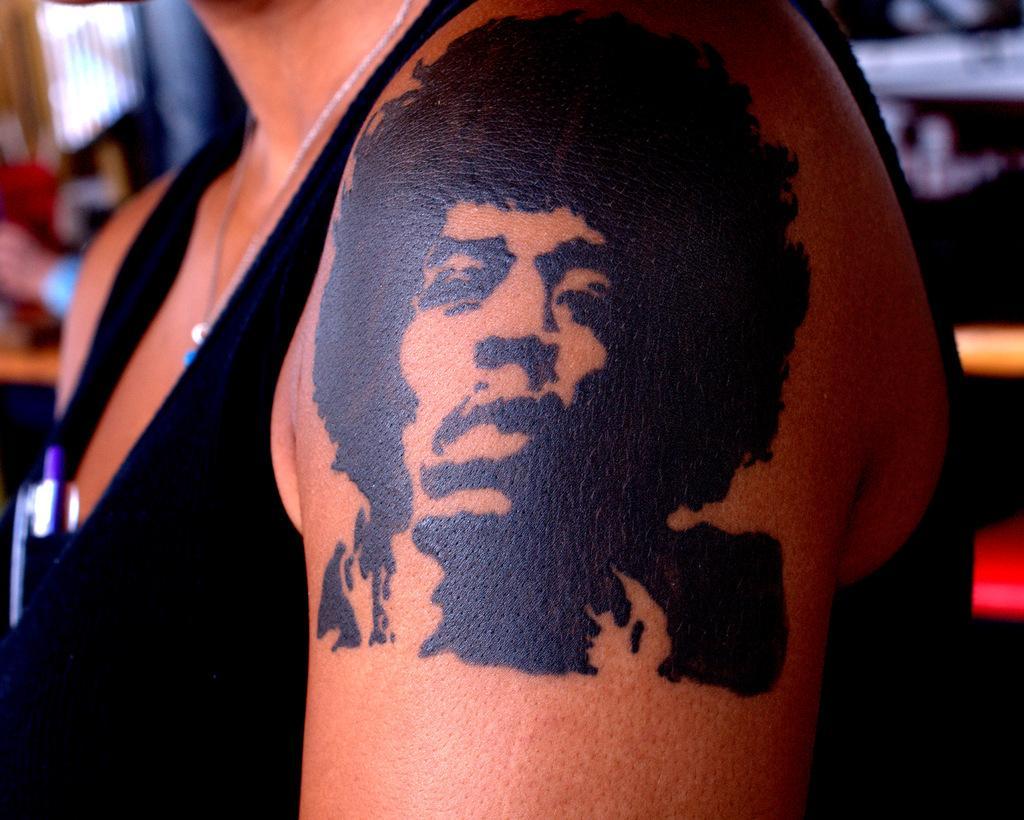Please provide a concise description of this image. In this picture there is a person wearing black dress and there is a tattoo on his arm. 